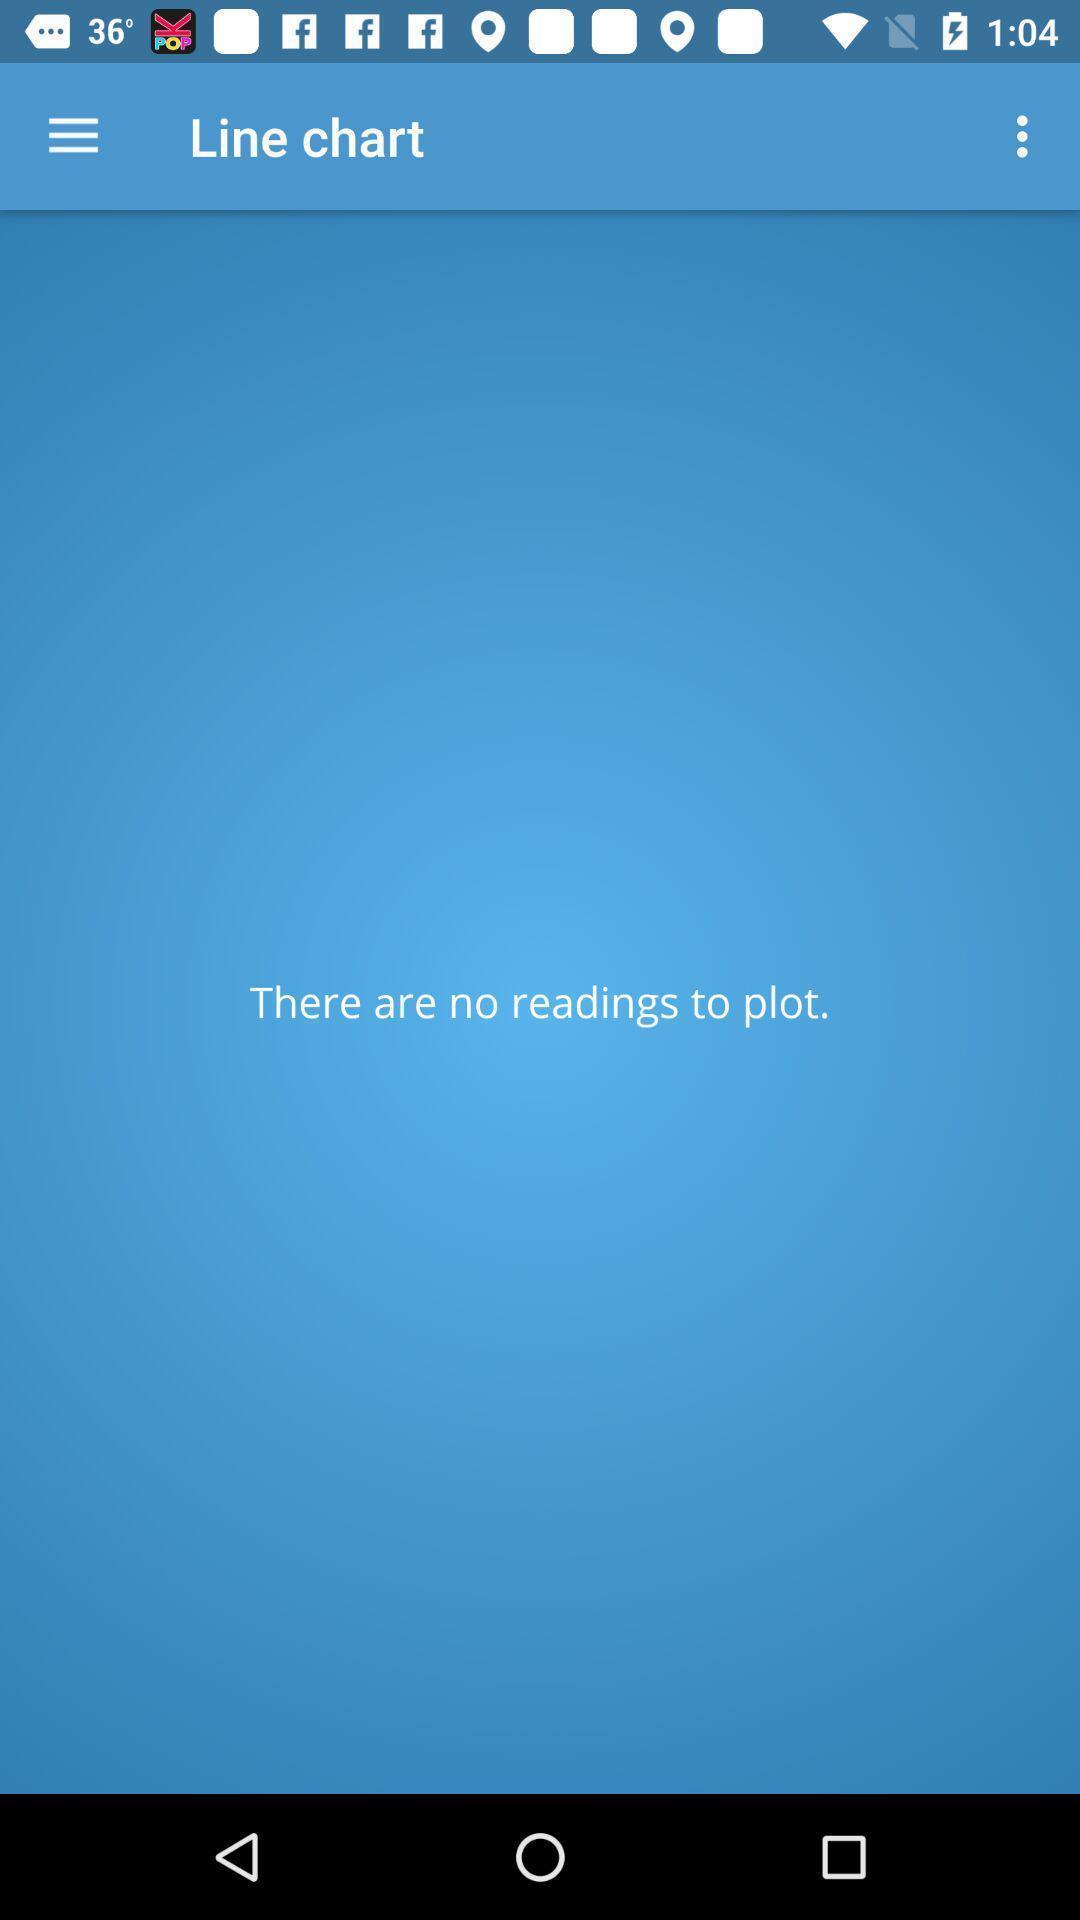Explain the elements present in this screenshot. Screen displaying line chart page. 